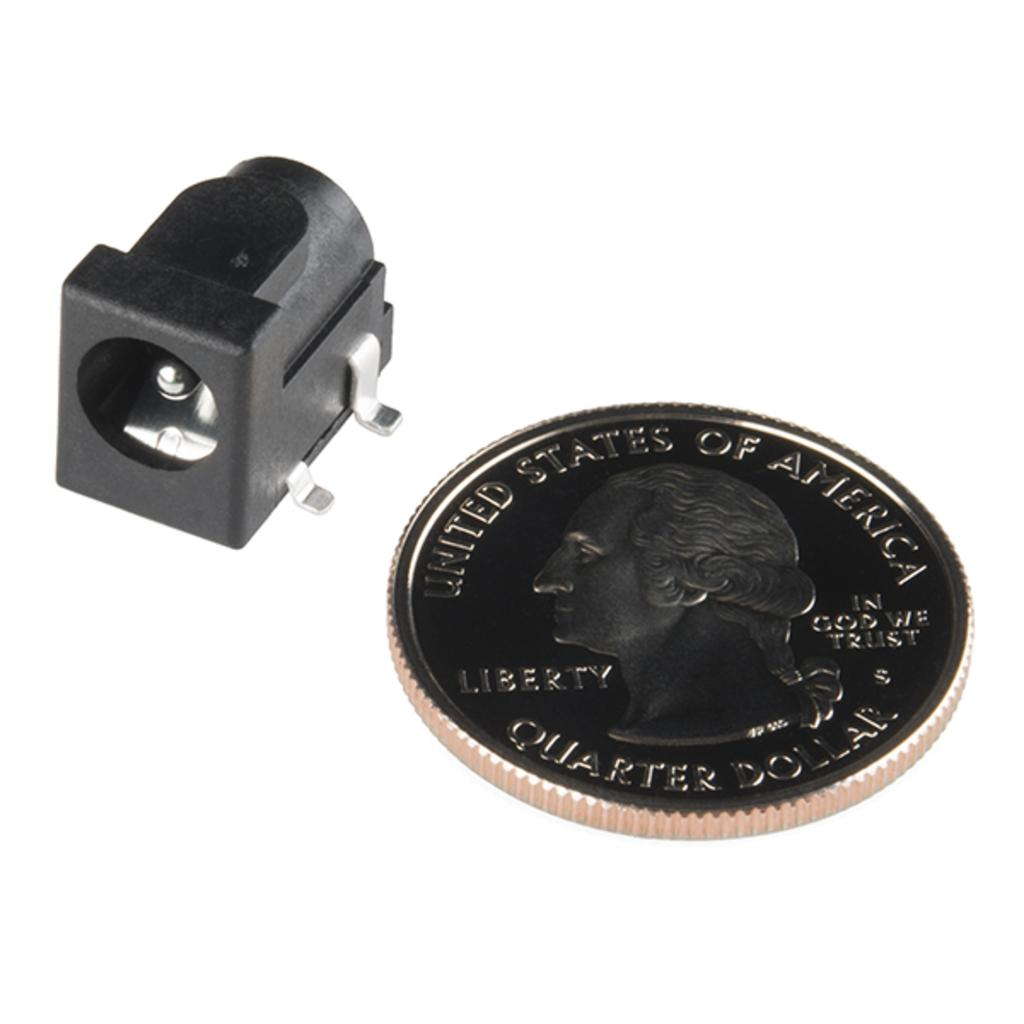What is the main subject of the image? There is a coin in the image. Can you describe the object in the image? Unfortunately, the only information provided is that there is an object in the image, so we cannot describe it further. What direction is the wool facing in the image? There is no wool present in the image. What is the value of the coin in the image? The value of the coin cannot be determined from the image alone, as it depends on factors such as the country of origin and the specific coin design. 